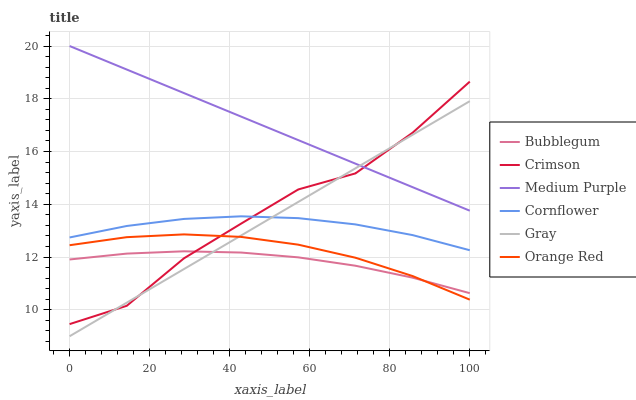Does Bubblegum have the minimum area under the curve?
Answer yes or no. Yes. Does Medium Purple have the maximum area under the curve?
Answer yes or no. Yes. Does Cornflower have the minimum area under the curve?
Answer yes or no. No. Does Cornflower have the maximum area under the curve?
Answer yes or no. No. Is Gray the smoothest?
Answer yes or no. Yes. Is Crimson the roughest?
Answer yes or no. Yes. Is Cornflower the smoothest?
Answer yes or no. No. Is Cornflower the roughest?
Answer yes or no. No. Does Gray have the lowest value?
Answer yes or no. Yes. Does Cornflower have the lowest value?
Answer yes or no. No. Does Medium Purple have the highest value?
Answer yes or no. Yes. Does Cornflower have the highest value?
Answer yes or no. No. Is Orange Red less than Medium Purple?
Answer yes or no. Yes. Is Medium Purple greater than Cornflower?
Answer yes or no. Yes. Does Gray intersect Medium Purple?
Answer yes or no. Yes. Is Gray less than Medium Purple?
Answer yes or no. No. Is Gray greater than Medium Purple?
Answer yes or no. No. Does Orange Red intersect Medium Purple?
Answer yes or no. No. 